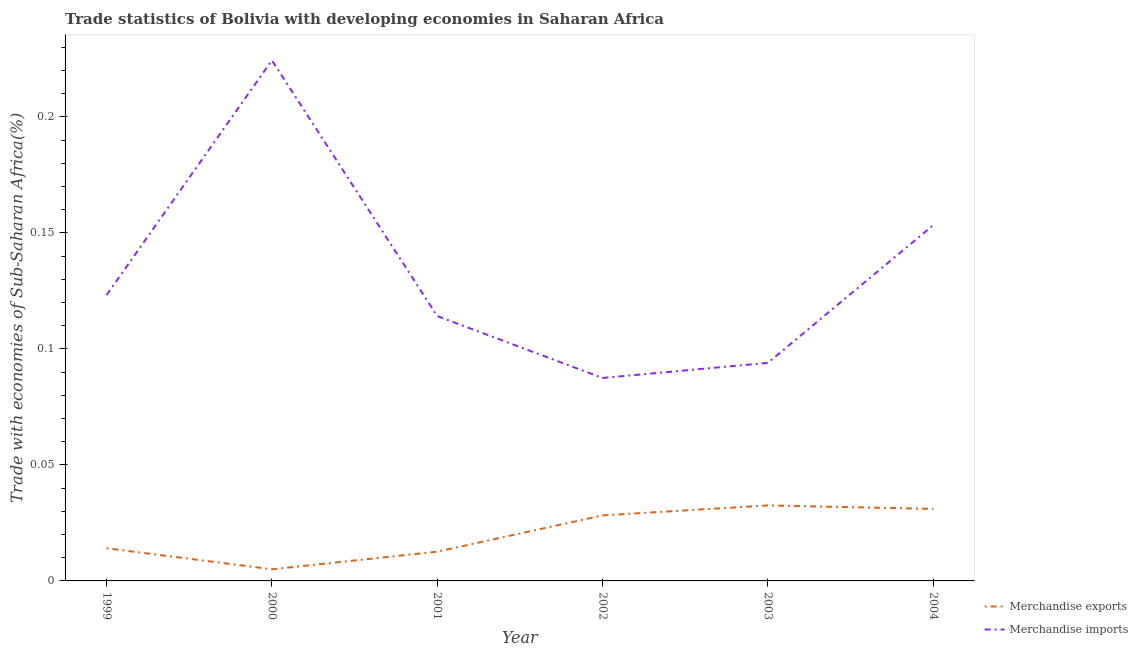How many different coloured lines are there?
Your answer should be very brief. 2. What is the merchandise exports in 1999?
Ensure brevity in your answer.  0.01. Across all years, what is the maximum merchandise exports?
Offer a very short reply. 0.03. Across all years, what is the minimum merchandise exports?
Provide a short and direct response. 0.01. In which year was the merchandise exports minimum?
Provide a short and direct response. 2000. What is the total merchandise exports in the graph?
Make the answer very short. 0.12. What is the difference between the merchandise imports in 2000 and that in 2004?
Offer a terse response. 0.07. What is the difference between the merchandise imports in 2004 and the merchandise exports in 2000?
Offer a terse response. 0.15. What is the average merchandise exports per year?
Make the answer very short. 0.02. In the year 2001, what is the difference between the merchandise exports and merchandise imports?
Make the answer very short. -0.1. In how many years, is the merchandise imports greater than 0.21000000000000002 %?
Offer a very short reply. 1. What is the ratio of the merchandise exports in 2000 to that in 2002?
Provide a short and direct response. 0.18. Is the merchandise exports in 2003 less than that in 2004?
Offer a terse response. No. What is the difference between the highest and the second highest merchandise exports?
Your response must be concise. 0. What is the difference between the highest and the lowest merchandise exports?
Ensure brevity in your answer.  0.03. Is the sum of the merchandise exports in 1999 and 2001 greater than the maximum merchandise imports across all years?
Offer a terse response. No. How many lines are there?
Make the answer very short. 2. Are the values on the major ticks of Y-axis written in scientific E-notation?
Give a very brief answer. No. Where does the legend appear in the graph?
Provide a short and direct response. Bottom right. How many legend labels are there?
Offer a very short reply. 2. What is the title of the graph?
Keep it short and to the point. Trade statistics of Bolivia with developing economies in Saharan Africa. What is the label or title of the Y-axis?
Offer a very short reply. Trade with economies of Sub-Saharan Africa(%). What is the Trade with economies of Sub-Saharan Africa(%) in Merchandise exports in 1999?
Your answer should be very brief. 0.01. What is the Trade with economies of Sub-Saharan Africa(%) in Merchandise imports in 1999?
Your answer should be compact. 0.12. What is the Trade with economies of Sub-Saharan Africa(%) of Merchandise exports in 2000?
Your response must be concise. 0.01. What is the Trade with economies of Sub-Saharan Africa(%) in Merchandise imports in 2000?
Ensure brevity in your answer.  0.22. What is the Trade with economies of Sub-Saharan Africa(%) in Merchandise exports in 2001?
Provide a succinct answer. 0.01. What is the Trade with economies of Sub-Saharan Africa(%) in Merchandise imports in 2001?
Your answer should be very brief. 0.11. What is the Trade with economies of Sub-Saharan Africa(%) of Merchandise exports in 2002?
Offer a very short reply. 0.03. What is the Trade with economies of Sub-Saharan Africa(%) in Merchandise imports in 2002?
Your response must be concise. 0.09. What is the Trade with economies of Sub-Saharan Africa(%) in Merchandise exports in 2003?
Ensure brevity in your answer.  0.03. What is the Trade with economies of Sub-Saharan Africa(%) in Merchandise imports in 2003?
Provide a short and direct response. 0.09. What is the Trade with economies of Sub-Saharan Africa(%) in Merchandise exports in 2004?
Provide a short and direct response. 0.03. What is the Trade with economies of Sub-Saharan Africa(%) of Merchandise imports in 2004?
Your answer should be compact. 0.15. Across all years, what is the maximum Trade with economies of Sub-Saharan Africa(%) in Merchandise exports?
Offer a very short reply. 0.03. Across all years, what is the maximum Trade with economies of Sub-Saharan Africa(%) of Merchandise imports?
Offer a very short reply. 0.22. Across all years, what is the minimum Trade with economies of Sub-Saharan Africa(%) of Merchandise exports?
Provide a short and direct response. 0.01. Across all years, what is the minimum Trade with economies of Sub-Saharan Africa(%) of Merchandise imports?
Provide a short and direct response. 0.09. What is the total Trade with economies of Sub-Saharan Africa(%) of Merchandise exports in the graph?
Make the answer very short. 0.12. What is the total Trade with economies of Sub-Saharan Africa(%) in Merchandise imports in the graph?
Offer a terse response. 0.8. What is the difference between the Trade with economies of Sub-Saharan Africa(%) in Merchandise exports in 1999 and that in 2000?
Ensure brevity in your answer.  0.01. What is the difference between the Trade with economies of Sub-Saharan Africa(%) in Merchandise imports in 1999 and that in 2000?
Ensure brevity in your answer.  -0.1. What is the difference between the Trade with economies of Sub-Saharan Africa(%) of Merchandise exports in 1999 and that in 2001?
Provide a short and direct response. 0. What is the difference between the Trade with economies of Sub-Saharan Africa(%) of Merchandise imports in 1999 and that in 2001?
Your answer should be very brief. 0.01. What is the difference between the Trade with economies of Sub-Saharan Africa(%) of Merchandise exports in 1999 and that in 2002?
Your response must be concise. -0.01. What is the difference between the Trade with economies of Sub-Saharan Africa(%) of Merchandise imports in 1999 and that in 2002?
Your answer should be compact. 0.04. What is the difference between the Trade with economies of Sub-Saharan Africa(%) of Merchandise exports in 1999 and that in 2003?
Give a very brief answer. -0.02. What is the difference between the Trade with economies of Sub-Saharan Africa(%) in Merchandise imports in 1999 and that in 2003?
Ensure brevity in your answer.  0.03. What is the difference between the Trade with economies of Sub-Saharan Africa(%) of Merchandise exports in 1999 and that in 2004?
Ensure brevity in your answer.  -0.02. What is the difference between the Trade with economies of Sub-Saharan Africa(%) in Merchandise imports in 1999 and that in 2004?
Keep it short and to the point. -0.03. What is the difference between the Trade with economies of Sub-Saharan Africa(%) of Merchandise exports in 2000 and that in 2001?
Offer a terse response. -0.01. What is the difference between the Trade with economies of Sub-Saharan Africa(%) in Merchandise imports in 2000 and that in 2001?
Offer a very short reply. 0.11. What is the difference between the Trade with economies of Sub-Saharan Africa(%) in Merchandise exports in 2000 and that in 2002?
Make the answer very short. -0.02. What is the difference between the Trade with economies of Sub-Saharan Africa(%) of Merchandise imports in 2000 and that in 2002?
Ensure brevity in your answer.  0.14. What is the difference between the Trade with economies of Sub-Saharan Africa(%) of Merchandise exports in 2000 and that in 2003?
Provide a short and direct response. -0.03. What is the difference between the Trade with economies of Sub-Saharan Africa(%) of Merchandise imports in 2000 and that in 2003?
Offer a terse response. 0.13. What is the difference between the Trade with economies of Sub-Saharan Africa(%) in Merchandise exports in 2000 and that in 2004?
Ensure brevity in your answer.  -0.03. What is the difference between the Trade with economies of Sub-Saharan Africa(%) of Merchandise imports in 2000 and that in 2004?
Provide a succinct answer. 0.07. What is the difference between the Trade with economies of Sub-Saharan Africa(%) in Merchandise exports in 2001 and that in 2002?
Offer a terse response. -0.02. What is the difference between the Trade with economies of Sub-Saharan Africa(%) in Merchandise imports in 2001 and that in 2002?
Provide a succinct answer. 0.03. What is the difference between the Trade with economies of Sub-Saharan Africa(%) in Merchandise exports in 2001 and that in 2003?
Offer a terse response. -0.02. What is the difference between the Trade with economies of Sub-Saharan Africa(%) of Merchandise imports in 2001 and that in 2003?
Make the answer very short. 0.02. What is the difference between the Trade with economies of Sub-Saharan Africa(%) in Merchandise exports in 2001 and that in 2004?
Provide a succinct answer. -0.02. What is the difference between the Trade with economies of Sub-Saharan Africa(%) of Merchandise imports in 2001 and that in 2004?
Offer a terse response. -0.04. What is the difference between the Trade with economies of Sub-Saharan Africa(%) of Merchandise exports in 2002 and that in 2003?
Make the answer very short. -0. What is the difference between the Trade with economies of Sub-Saharan Africa(%) in Merchandise imports in 2002 and that in 2003?
Provide a short and direct response. -0.01. What is the difference between the Trade with economies of Sub-Saharan Africa(%) of Merchandise exports in 2002 and that in 2004?
Offer a very short reply. -0. What is the difference between the Trade with economies of Sub-Saharan Africa(%) of Merchandise imports in 2002 and that in 2004?
Provide a short and direct response. -0.07. What is the difference between the Trade with economies of Sub-Saharan Africa(%) of Merchandise exports in 2003 and that in 2004?
Provide a short and direct response. 0. What is the difference between the Trade with economies of Sub-Saharan Africa(%) of Merchandise imports in 2003 and that in 2004?
Provide a short and direct response. -0.06. What is the difference between the Trade with economies of Sub-Saharan Africa(%) of Merchandise exports in 1999 and the Trade with economies of Sub-Saharan Africa(%) of Merchandise imports in 2000?
Give a very brief answer. -0.21. What is the difference between the Trade with economies of Sub-Saharan Africa(%) in Merchandise exports in 1999 and the Trade with economies of Sub-Saharan Africa(%) in Merchandise imports in 2001?
Provide a short and direct response. -0.1. What is the difference between the Trade with economies of Sub-Saharan Africa(%) in Merchandise exports in 1999 and the Trade with economies of Sub-Saharan Africa(%) in Merchandise imports in 2002?
Provide a short and direct response. -0.07. What is the difference between the Trade with economies of Sub-Saharan Africa(%) of Merchandise exports in 1999 and the Trade with economies of Sub-Saharan Africa(%) of Merchandise imports in 2003?
Your answer should be very brief. -0.08. What is the difference between the Trade with economies of Sub-Saharan Africa(%) in Merchandise exports in 1999 and the Trade with economies of Sub-Saharan Africa(%) in Merchandise imports in 2004?
Make the answer very short. -0.14. What is the difference between the Trade with economies of Sub-Saharan Africa(%) in Merchandise exports in 2000 and the Trade with economies of Sub-Saharan Africa(%) in Merchandise imports in 2001?
Keep it short and to the point. -0.11. What is the difference between the Trade with economies of Sub-Saharan Africa(%) of Merchandise exports in 2000 and the Trade with economies of Sub-Saharan Africa(%) of Merchandise imports in 2002?
Ensure brevity in your answer.  -0.08. What is the difference between the Trade with economies of Sub-Saharan Africa(%) in Merchandise exports in 2000 and the Trade with economies of Sub-Saharan Africa(%) in Merchandise imports in 2003?
Provide a succinct answer. -0.09. What is the difference between the Trade with economies of Sub-Saharan Africa(%) of Merchandise exports in 2000 and the Trade with economies of Sub-Saharan Africa(%) of Merchandise imports in 2004?
Offer a very short reply. -0.15. What is the difference between the Trade with economies of Sub-Saharan Africa(%) in Merchandise exports in 2001 and the Trade with economies of Sub-Saharan Africa(%) in Merchandise imports in 2002?
Offer a terse response. -0.07. What is the difference between the Trade with economies of Sub-Saharan Africa(%) in Merchandise exports in 2001 and the Trade with economies of Sub-Saharan Africa(%) in Merchandise imports in 2003?
Offer a terse response. -0.08. What is the difference between the Trade with economies of Sub-Saharan Africa(%) of Merchandise exports in 2001 and the Trade with economies of Sub-Saharan Africa(%) of Merchandise imports in 2004?
Provide a succinct answer. -0.14. What is the difference between the Trade with economies of Sub-Saharan Africa(%) of Merchandise exports in 2002 and the Trade with economies of Sub-Saharan Africa(%) of Merchandise imports in 2003?
Offer a very short reply. -0.07. What is the difference between the Trade with economies of Sub-Saharan Africa(%) in Merchandise exports in 2002 and the Trade with economies of Sub-Saharan Africa(%) in Merchandise imports in 2004?
Provide a succinct answer. -0.13. What is the difference between the Trade with economies of Sub-Saharan Africa(%) in Merchandise exports in 2003 and the Trade with economies of Sub-Saharan Africa(%) in Merchandise imports in 2004?
Provide a succinct answer. -0.12. What is the average Trade with economies of Sub-Saharan Africa(%) of Merchandise exports per year?
Offer a very short reply. 0.02. What is the average Trade with economies of Sub-Saharan Africa(%) in Merchandise imports per year?
Ensure brevity in your answer.  0.13. In the year 1999, what is the difference between the Trade with economies of Sub-Saharan Africa(%) in Merchandise exports and Trade with economies of Sub-Saharan Africa(%) in Merchandise imports?
Your answer should be very brief. -0.11. In the year 2000, what is the difference between the Trade with economies of Sub-Saharan Africa(%) of Merchandise exports and Trade with economies of Sub-Saharan Africa(%) of Merchandise imports?
Ensure brevity in your answer.  -0.22. In the year 2001, what is the difference between the Trade with economies of Sub-Saharan Africa(%) in Merchandise exports and Trade with economies of Sub-Saharan Africa(%) in Merchandise imports?
Ensure brevity in your answer.  -0.1. In the year 2002, what is the difference between the Trade with economies of Sub-Saharan Africa(%) of Merchandise exports and Trade with economies of Sub-Saharan Africa(%) of Merchandise imports?
Offer a very short reply. -0.06. In the year 2003, what is the difference between the Trade with economies of Sub-Saharan Africa(%) in Merchandise exports and Trade with economies of Sub-Saharan Africa(%) in Merchandise imports?
Provide a succinct answer. -0.06. In the year 2004, what is the difference between the Trade with economies of Sub-Saharan Africa(%) of Merchandise exports and Trade with economies of Sub-Saharan Africa(%) of Merchandise imports?
Offer a very short reply. -0.12. What is the ratio of the Trade with economies of Sub-Saharan Africa(%) of Merchandise exports in 1999 to that in 2000?
Your answer should be compact. 2.81. What is the ratio of the Trade with economies of Sub-Saharan Africa(%) in Merchandise imports in 1999 to that in 2000?
Provide a succinct answer. 0.55. What is the ratio of the Trade with economies of Sub-Saharan Africa(%) of Merchandise exports in 1999 to that in 2001?
Ensure brevity in your answer.  1.12. What is the ratio of the Trade with economies of Sub-Saharan Africa(%) in Merchandise imports in 1999 to that in 2001?
Your answer should be very brief. 1.08. What is the ratio of the Trade with economies of Sub-Saharan Africa(%) in Merchandise exports in 1999 to that in 2002?
Provide a succinct answer. 0.5. What is the ratio of the Trade with economies of Sub-Saharan Africa(%) of Merchandise imports in 1999 to that in 2002?
Your response must be concise. 1.41. What is the ratio of the Trade with economies of Sub-Saharan Africa(%) of Merchandise exports in 1999 to that in 2003?
Offer a terse response. 0.43. What is the ratio of the Trade with economies of Sub-Saharan Africa(%) in Merchandise imports in 1999 to that in 2003?
Provide a short and direct response. 1.31. What is the ratio of the Trade with economies of Sub-Saharan Africa(%) in Merchandise exports in 1999 to that in 2004?
Ensure brevity in your answer.  0.45. What is the ratio of the Trade with economies of Sub-Saharan Africa(%) in Merchandise imports in 1999 to that in 2004?
Make the answer very short. 0.8. What is the ratio of the Trade with economies of Sub-Saharan Africa(%) of Merchandise exports in 2000 to that in 2001?
Your answer should be very brief. 0.4. What is the ratio of the Trade with economies of Sub-Saharan Africa(%) in Merchandise imports in 2000 to that in 2001?
Your answer should be very brief. 1.97. What is the ratio of the Trade with economies of Sub-Saharan Africa(%) in Merchandise exports in 2000 to that in 2002?
Keep it short and to the point. 0.18. What is the ratio of the Trade with economies of Sub-Saharan Africa(%) in Merchandise imports in 2000 to that in 2002?
Offer a terse response. 2.57. What is the ratio of the Trade with economies of Sub-Saharan Africa(%) of Merchandise exports in 2000 to that in 2003?
Offer a very short reply. 0.15. What is the ratio of the Trade with economies of Sub-Saharan Africa(%) in Merchandise imports in 2000 to that in 2003?
Your answer should be compact. 2.39. What is the ratio of the Trade with economies of Sub-Saharan Africa(%) of Merchandise exports in 2000 to that in 2004?
Offer a very short reply. 0.16. What is the ratio of the Trade with economies of Sub-Saharan Africa(%) in Merchandise imports in 2000 to that in 2004?
Offer a very short reply. 1.46. What is the ratio of the Trade with economies of Sub-Saharan Africa(%) of Merchandise exports in 2001 to that in 2002?
Ensure brevity in your answer.  0.45. What is the ratio of the Trade with economies of Sub-Saharan Africa(%) in Merchandise imports in 2001 to that in 2002?
Your answer should be very brief. 1.31. What is the ratio of the Trade with economies of Sub-Saharan Africa(%) in Merchandise exports in 2001 to that in 2003?
Your response must be concise. 0.39. What is the ratio of the Trade with economies of Sub-Saharan Africa(%) of Merchandise imports in 2001 to that in 2003?
Keep it short and to the point. 1.21. What is the ratio of the Trade with economies of Sub-Saharan Africa(%) of Merchandise exports in 2001 to that in 2004?
Your response must be concise. 0.41. What is the ratio of the Trade with economies of Sub-Saharan Africa(%) of Merchandise imports in 2001 to that in 2004?
Provide a succinct answer. 0.74. What is the ratio of the Trade with economies of Sub-Saharan Africa(%) of Merchandise exports in 2002 to that in 2003?
Offer a very short reply. 0.87. What is the ratio of the Trade with economies of Sub-Saharan Africa(%) of Merchandise imports in 2002 to that in 2003?
Offer a terse response. 0.93. What is the ratio of the Trade with economies of Sub-Saharan Africa(%) in Merchandise exports in 2002 to that in 2004?
Your answer should be compact. 0.91. What is the ratio of the Trade with economies of Sub-Saharan Africa(%) in Merchandise imports in 2002 to that in 2004?
Make the answer very short. 0.57. What is the ratio of the Trade with economies of Sub-Saharan Africa(%) of Merchandise exports in 2003 to that in 2004?
Your answer should be compact. 1.05. What is the ratio of the Trade with economies of Sub-Saharan Africa(%) in Merchandise imports in 2003 to that in 2004?
Keep it short and to the point. 0.61. What is the difference between the highest and the second highest Trade with economies of Sub-Saharan Africa(%) of Merchandise exports?
Offer a very short reply. 0. What is the difference between the highest and the second highest Trade with economies of Sub-Saharan Africa(%) of Merchandise imports?
Your response must be concise. 0.07. What is the difference between the highest and the lowest Trade with economies of Sub-Saharan Africa(%) in Merchandise exports?
Ensure brevity in your answer.  0.03. What is the difference between the highest and the lowest Trade with economies of Sub-Saharan Africa(%) of Merchandise imports?
Your response must be concise. 0.14. 